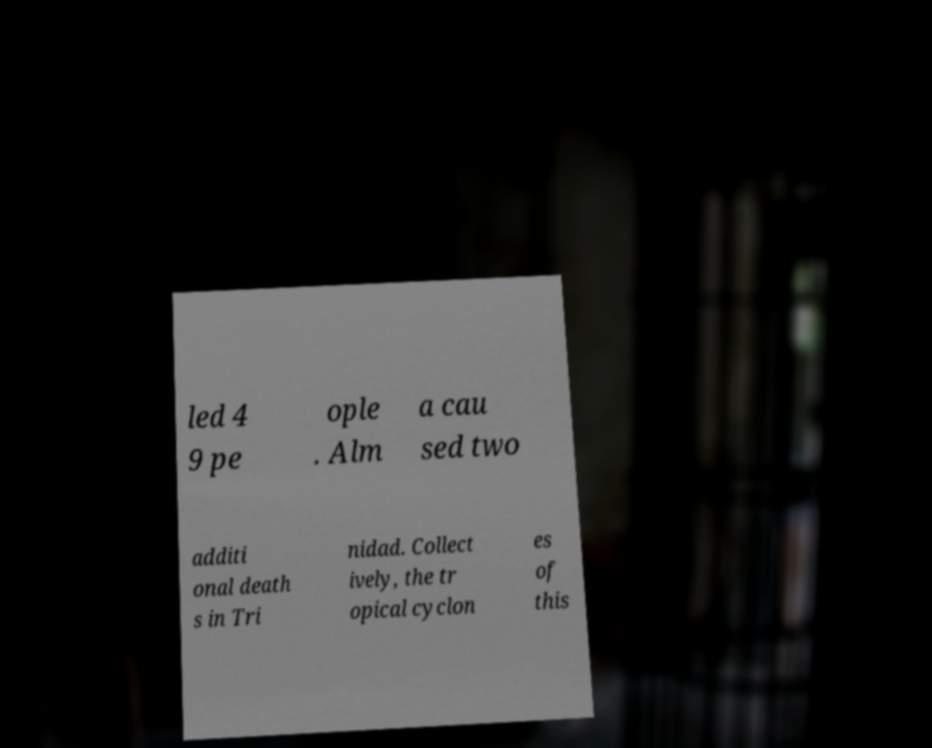Could you extract and type out the text from this image? led 4 9 pe ople . Alm a cau sed two additi onal death s in Tri nidad. Collect ively, the tr opical cyclon es of this 